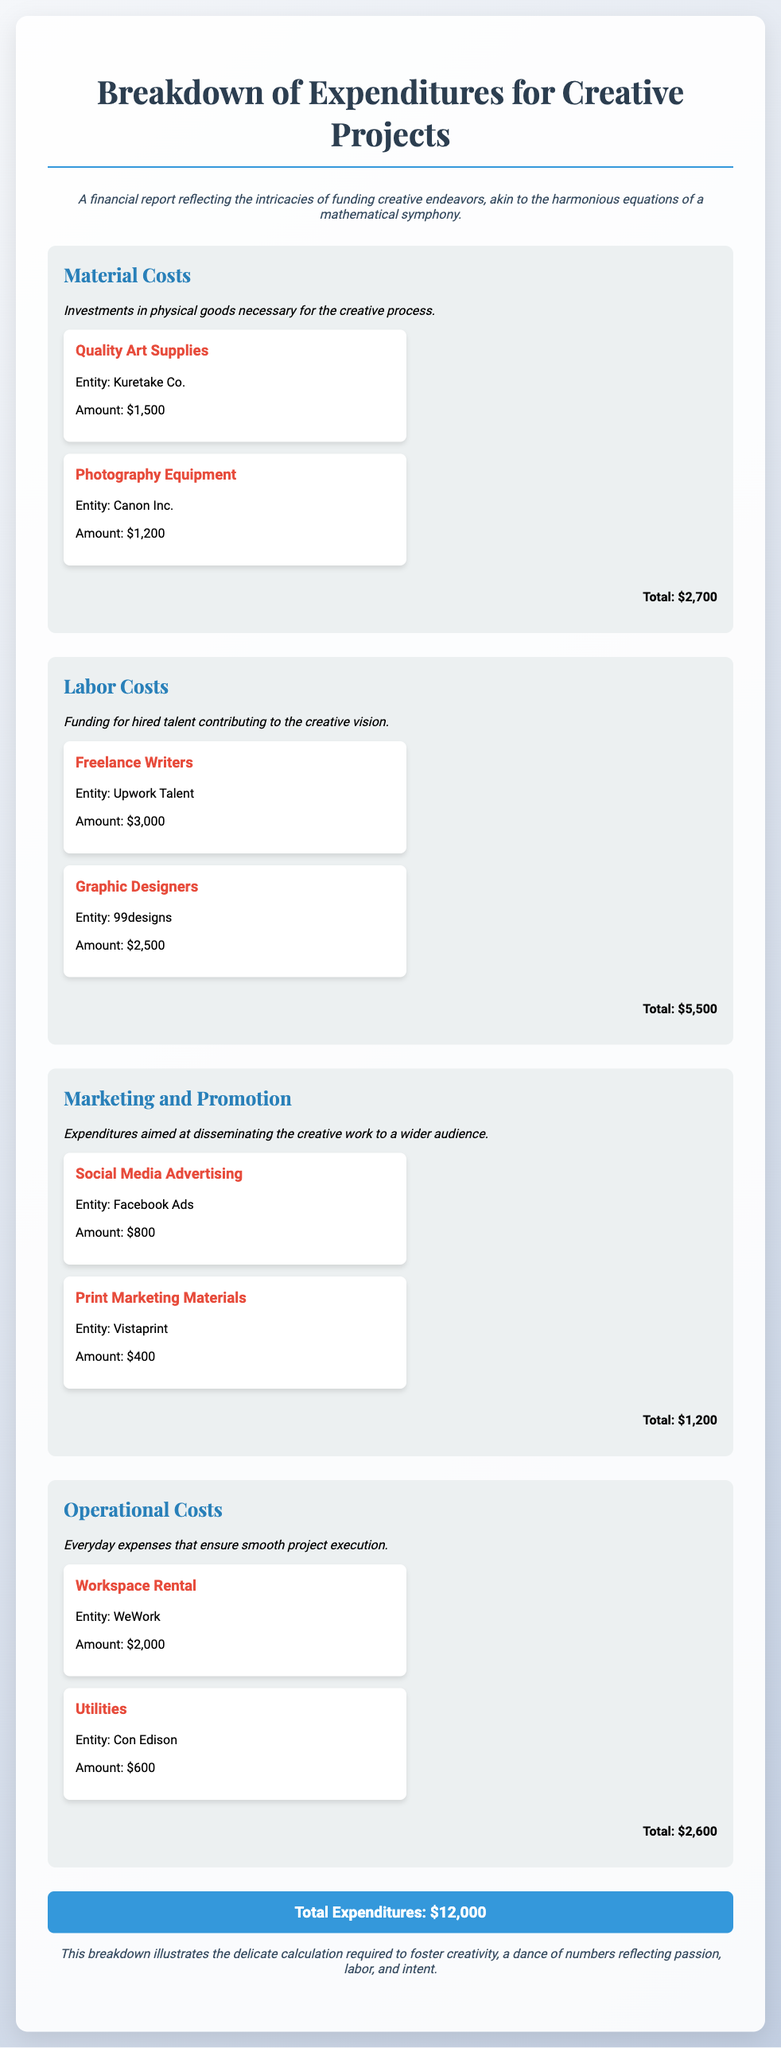what is the total amount spent on Material Costs? The total amount for Material Costs is the sum of all entries listed under that category, which is $1,500 + $1,200.
Answer: $2,700 who was hired for freelance writing services? The example provided for freelance writing services is from Upwork Talent, which is stated in the document.
Answer: Upwork Talent how much was spent on Graphic Designers? The amount spent on Graphic Designers is specifically provided in the Labor Costs section as $2,500.
Answer: $2,500 which entity provided the Photography Equipment? The document mentions Canon Inc. as the entity that supplied the Photography Equipment.
Answer: Canon Inc what is the total for Marketing and Promotion expenditures? The total for Marketing and Promotion is derived from the amounts listed, which adds up to $800 + $400.
Answer: $1,200 how much were the total expenditures for Creative Projects? The grand total of expenditures is calculated and stated at the bottom of the document, reflecting all categories together.
Answer: $12,000 what type of costs does the category 'Operational Costs' include? 'Operational Costs' encompasses everyday expenses necessary for project execution, as detailed in the document.
Answer: Everyday expenses who is responsible for social media advertising? The entity responsible for social media advertising mentioned in the document is Facebook Ads.
Answer: Facebook Ads what is the largest category of expenditures? By comparing the totals listed under each category, Labor Costs at $5,500 is the largest.
Answer: Labor Costs 